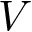<formula> <loc_0><loc_0><loc_500><loc_500>V</formula> 